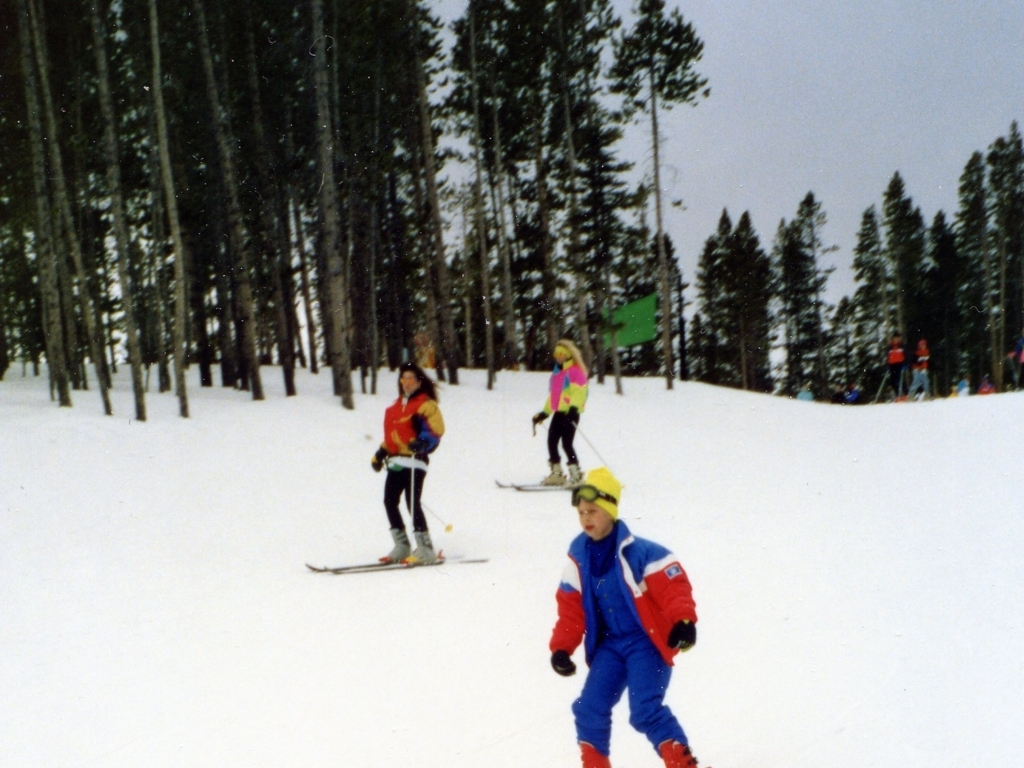Are there any safety measures that the skiers should follow which is visible in the image? The skiers should be wearing protective helmets to reduce the risk of head injury in case of falls or collisions. Additionally, staying within the marked trails, as suggested by the green sign on the right, helps in maintaining a safe skiing environment. 